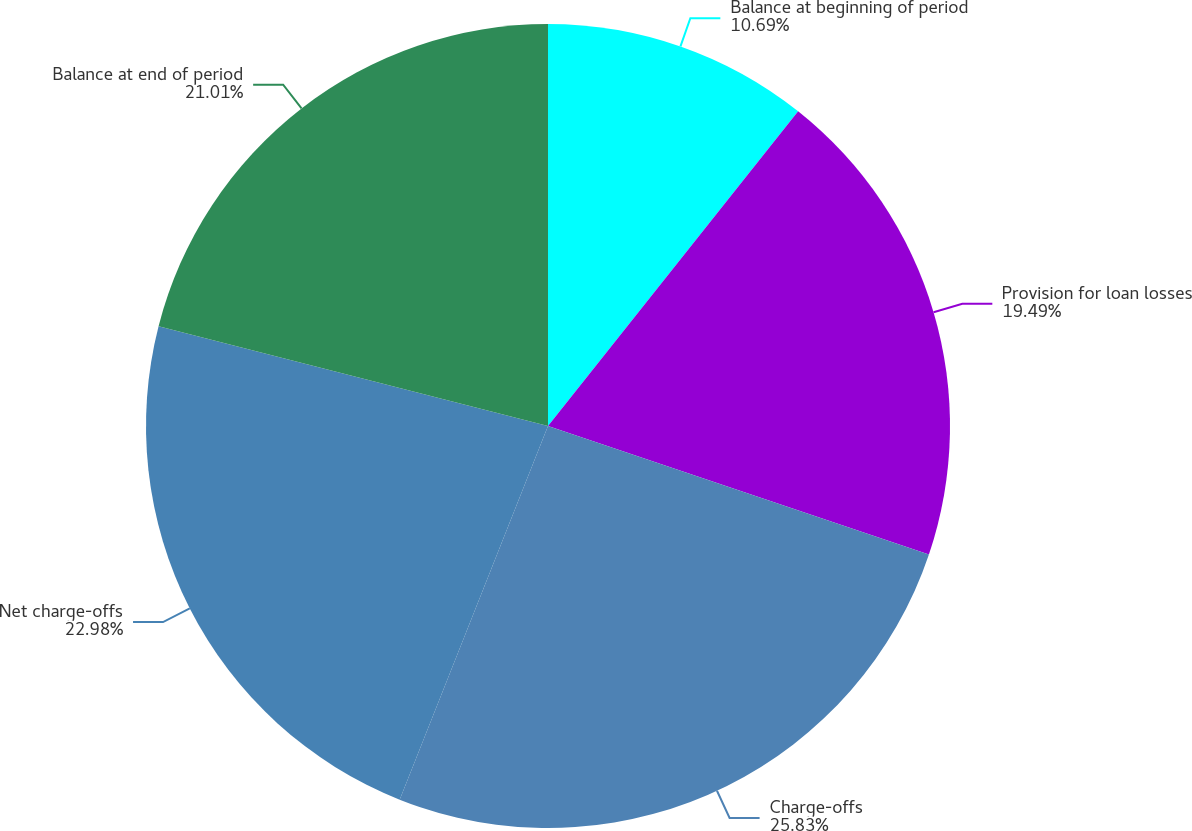Convert chart to OTSL. <chart><loc_0><loc_0><loc_500><loc_500><pie_chart><fcel>Balance at beginning of period<fcel>Provision for loan losses<fcel>Charge-offs<fcel>Net charge-offs<fcel>Balance at end of period<nl><fcel>10.69%<fcel>19.49%<fcel>25.84%<fcel>22.98%<fcel>21.01%<nl></chart> 